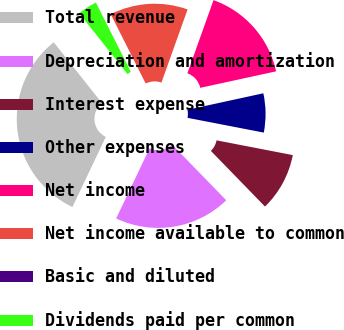Convert chart. <chart><loc_0><loc_0><loc_500><loc_500><pie_chart><fcel>Total revenue<fcel>Depreciation and amortization<fcel>Interest expense<fcel>Other expenses<fcel>Net income<fcel>Net income available to common<fcel>Basic and diluted<fcel>Dividends paid per common<nl><fcel>32.26%<fcel>19.35%<fcel>9.68%<fcel>6.45%<fcel>16.13%<fcel>12.9%<fcel>0.0%<fcel>3.23%<nl></chart> 